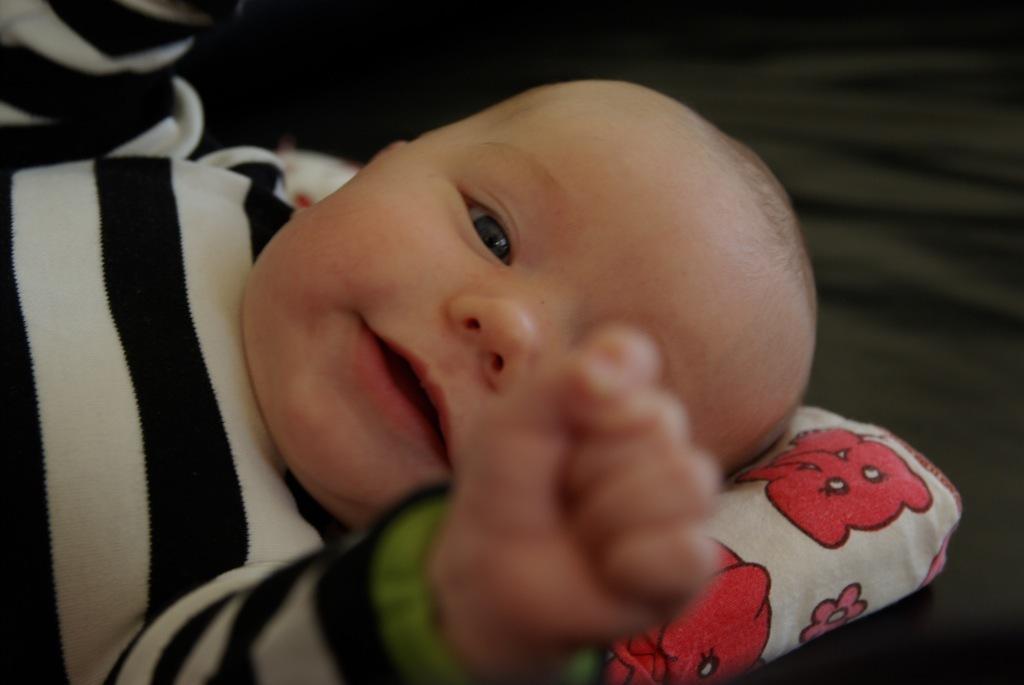Can you describe this image briefly? In this image, we can see a baby on pillow. In the background, image is blurred. 